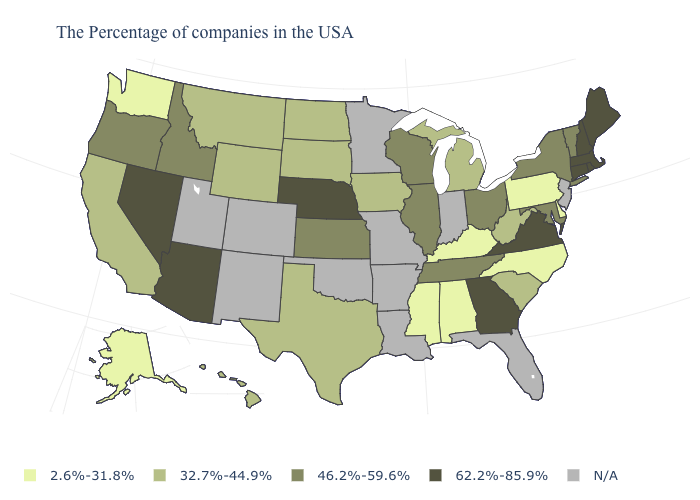Does the first symbol in the legend represent the smallest category?
Give a very brief answer. Yes. Does the map have missing data?
Concise answer only. Yes. Does the map have missing data?
Concise answer only. Yes. What is the value of Ohio?
Be succinct. 46.2%-59.6%. What is the value of New Hampshire?
Give a very brief answer. 62.2%-85.9%. What is the lowest value in the Northeast?
Quick response, please. 2.6%-31.8%. Which states have the highest value in the USA?
Be succinct. Maine, Massachusetts, Rhode Island, New Hampshire, Connecticut, Virginia, Georgia, Nebraska, Arizona, Nevada. What is the lowest value in states that border Missouri?
Short answer required. 2.6%-31.8%. Name the states that have a value in the range 2.6%-31.8%?
Quick response, please. Delaware, Pennsylvania, North Carolina, Kentucky, Alabama, Mississippi, Washington, Alaska. Does the map have missing data?
Write a very short answer. Yes. Does Maine have the highest value in the Northeast?
Write a very short answer. Yes. Among the states that border Washington , which have the lowest value?
Quick response, please. Idaho, Oregon. Name the states that have a value in the range 32.7%-44.9%?
Quick response, please. South Carolina, West Virginia, Michigan, Iowa, Texas, South Dakota, North Dakota, Wyoming, Montana, California, Hawaii. Name the states that have a value in the range 2.6%-31.8%?
Answer briefly. Delaware, Pennsylvania, North Carolina, Kentucky, Alabama, Mississippi, Washington, Alaska. 